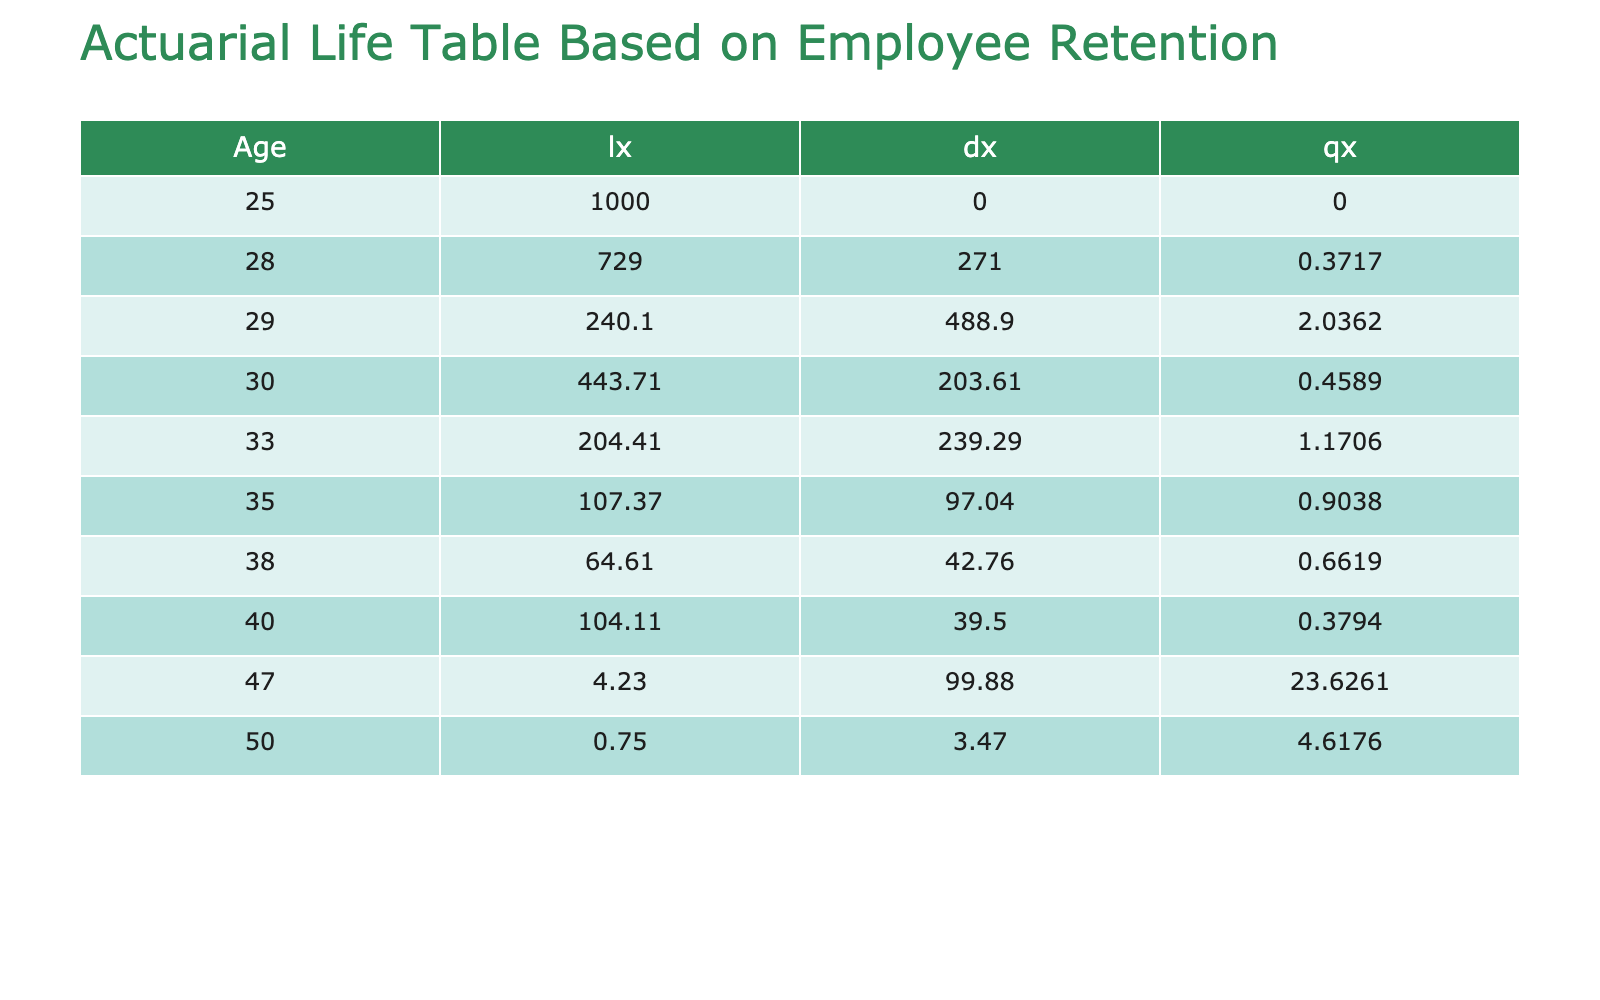What is the highest post-initiatives retention rate? The highest post-initiatives retention rate in the table is found in the row for Clean Energy Solutions, which shows a retention rate of 88%.
Answer: 88% Which company implemented zero waste initiatives? The company that implemented zero waste initiatives is Renewable Sources, as indicated in the Eco-Friendly Initiative Implemented column.
Answer: Renewable Sources What is the average pre-initiatives retention rate across all companies? To find the average pre-initiatives retention rate, sum all the pre-initiatives rates (70 + 65 + 60 + 75 + 68 + 72 + 62 + 65 + 55 + 66 =  688) and divide by the number of companies (10). The average is 688 / 10 = 68.8%.
Answer: 68.8 Is the yearly turnover rate of Urban Green Architects higher than 15%? The yearly turnover rate for Urban Green Architects is 14%, which is lower than 15%, so the statement is false.
Answer: No Which industry has the lowest post-initiatives retention rate, and what is that rate? To find the industry with the lowest post-initiatives retention rate, look through the Post-Initiatives Retention Rate column. The lowest rate is 73% for EcoPrint Media.
Answer: EcoPrint Media, 73% What is the difference between the pre-initiatives and post-initiatives retention rates for Sustainable Apparel Co.? The pre-initiatives retention rate for Sustainable Apparel Co. is 60%, and the post-initiatives rate is 78%. The difference is 78 - 60 = 18%.
Answer: 18% How many companies have a post-initiatives retention rate greater than 80%? By examining the Post-Initiatives Retention Rate column, the companies with rates greater than 80% are GreenTech Innovations, Clean Energy Solutions, Urban Green Architects, Sustaina-Living, and EcoFriendly Logistics. In total, there are 5 such companies.
Answer: 5 What is the average yearly turnover rate of all companies? The average yearly turnover rate is calculated by summing all turnover rates (12 + 15 + 20 + 10 + 18 + 14 + 22 + 25 + 30 + 19 =  175) and dividing by the number of companies (10). The average is 175 / 10 = 17.5%.
Answer: 17.5 Do all companies with an age over 30 have a post-initiatives retention rate above 75%? Examining the ages and retention rates, the companies over 30 are EcoFriendly Logistics, Sustainable Apparel Co., Urban Green Architects, Renewable Sources, Planet Care Cleaning Services, and Sustaina-Living. Among these, Sustainable Apparel Co. has a post-initiatives retention rate of 78%, which is below 75%. Thus, the statement is false.
Answer: No 